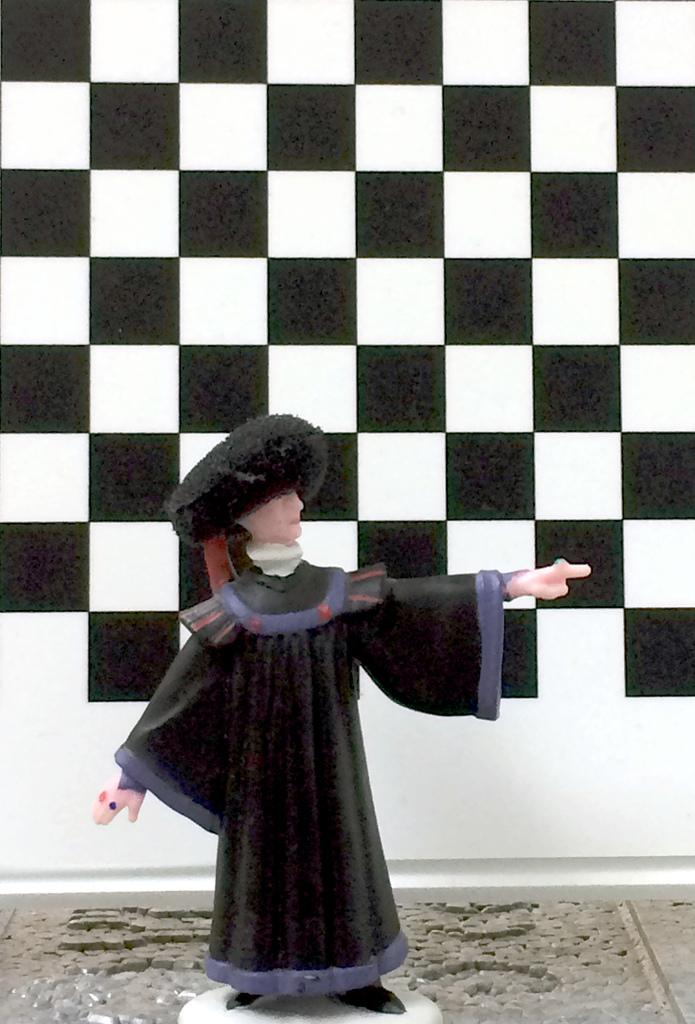What is the main subject in the center of the image? There is a statue in the center of the image. What can be seen behind the statue? There is a wall at the back side of the image. How many ants are crawling on the statue in the image? There are no ants present on the statue in the image. What type of agreement is being discussed in the image? There is no discussion or agreement present in the image; it features a statue and a wall. 